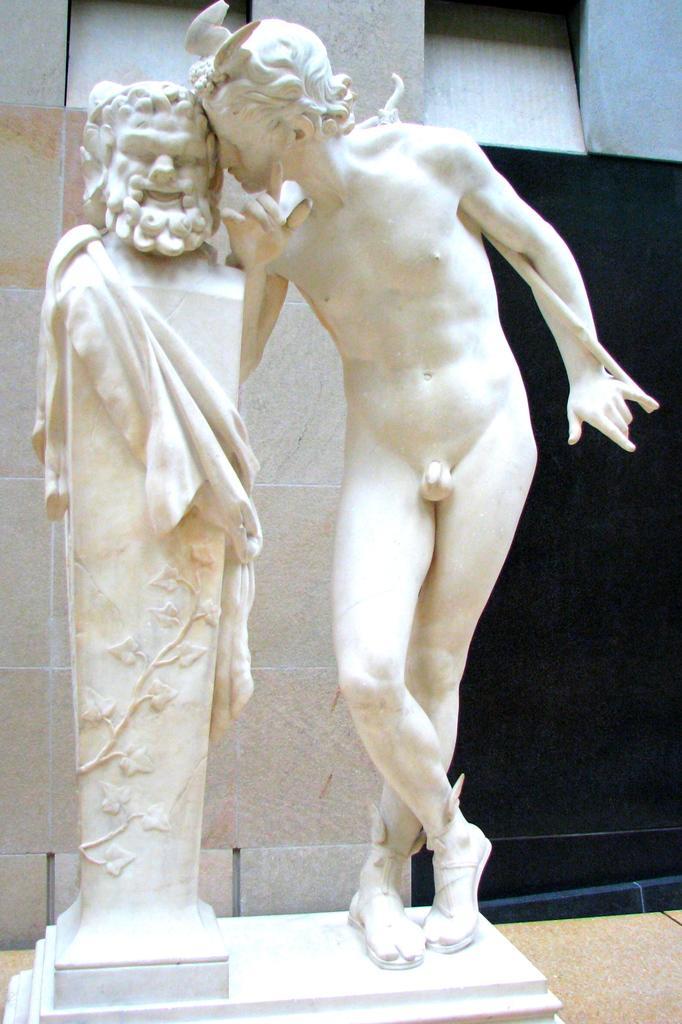Can you describe this image briefly? In this image we can see a sculpture. There is a wall behind the sculpture. 